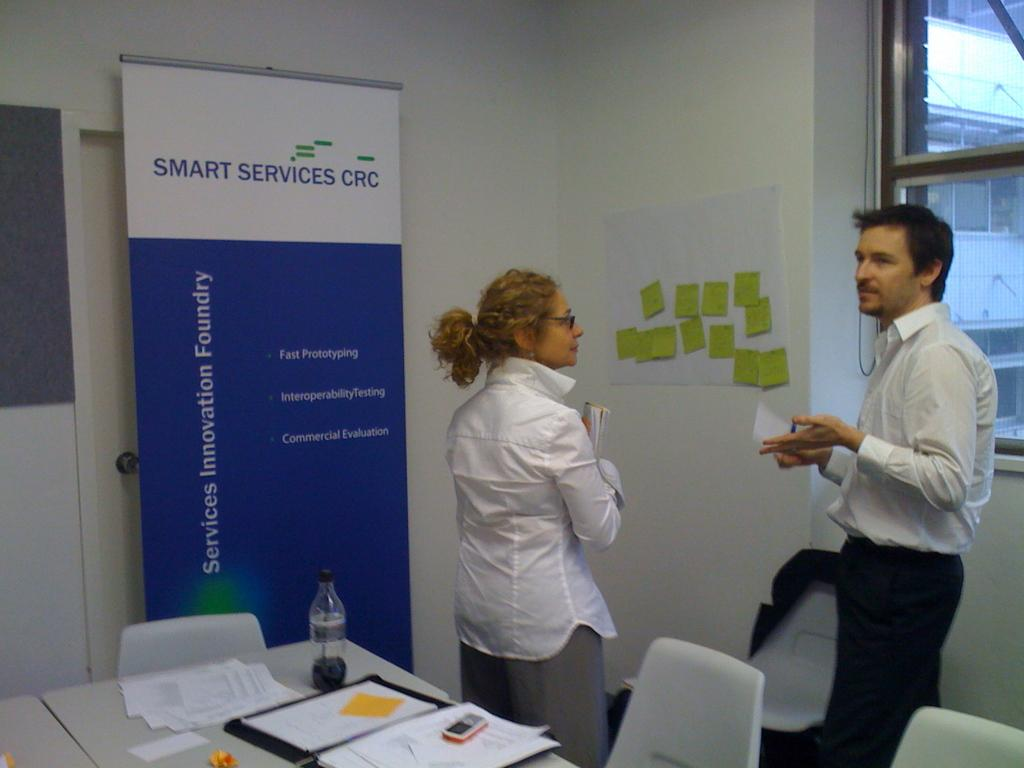Provide a one-sentence caption for the provided image. a sign next to people called smart services crc. 